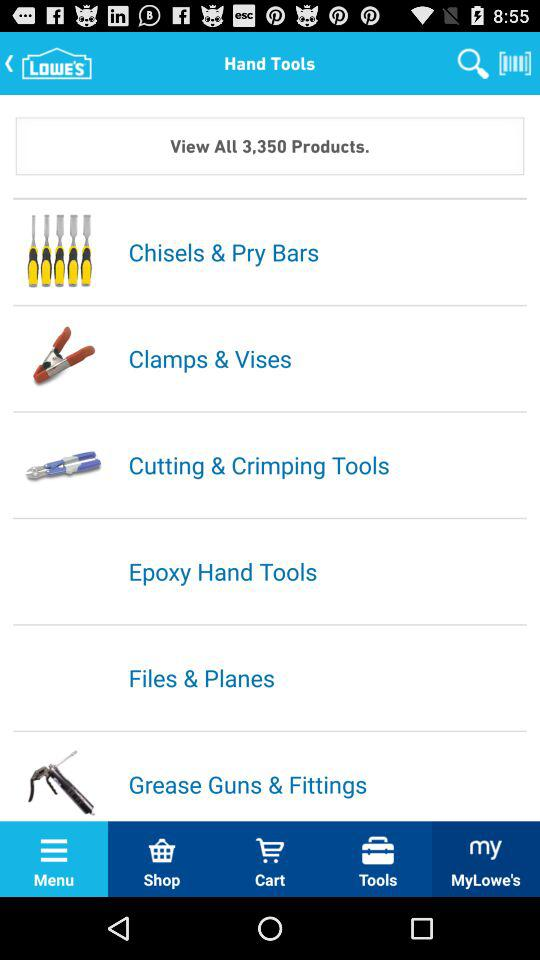How many products are there? There are 3,350 products. 